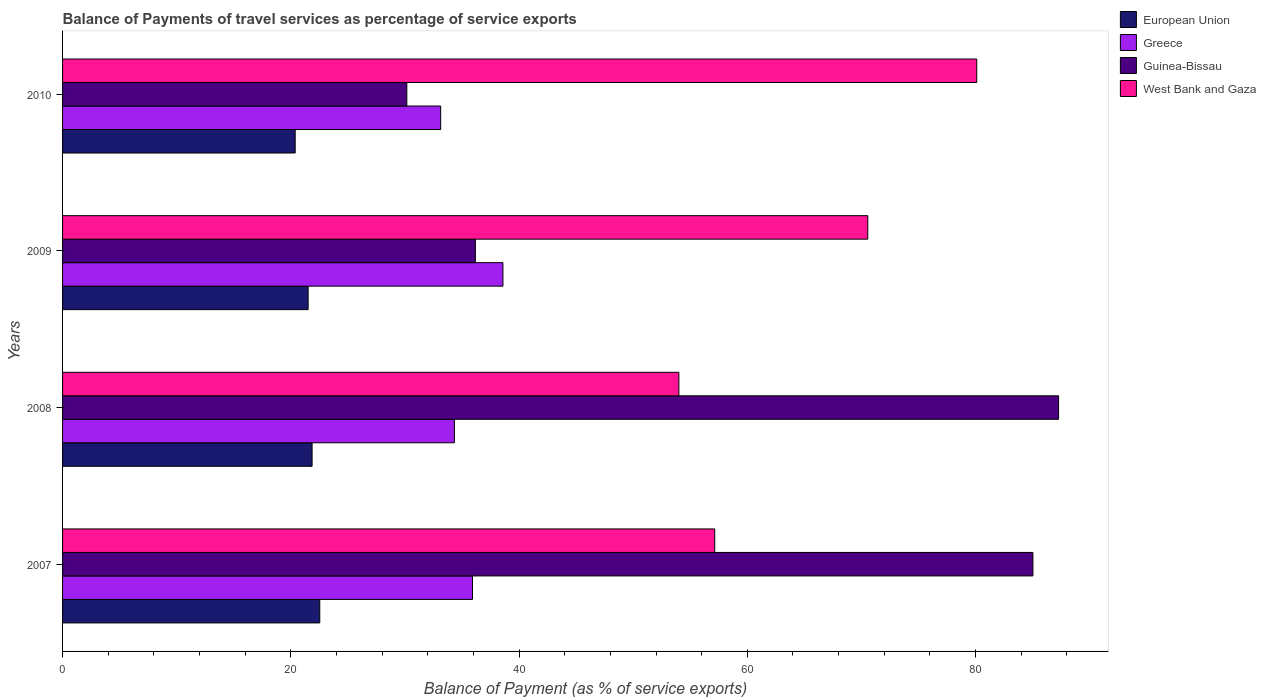How many different coloured bars are there?
Keep it short and to the point. 4. How many groups of bars are there?
Your response must be concise. 4. Are the number of bars on each tick of the Y-axis equal?
Make the answer very short. Yes. What is the balance of payments of travel services in West Bank and Gaza in 2007?
Ensure brevity in your answer.  57.14. Across all years, what is the maximum balance of payments of travel services in Greece?
Your answer should be very brief. 38.59. Across all years, what is the minimum balance of payments of travel services in West Bank and Gaza?
Provide a succinct answer. 54. In which year was the balance of payments of travel services in Guinea-Bissau maximum?
Your answer should be very brief. 2008. In which year was the balance of payments of travel services in European Union minimum?
Give a very brief answer. 2010. What is the total balance of payments of travel services in West Bank and Gaza in the graph?
Provide a short and direct response. 261.81. What is the difference between the balance of payments of travel services in Greece in 2007 and that in 2009?
Your answer should be very brief. -2.67. What is the difference between the balance of payments of travel services in West Bank and Gaza in 2009 and the balance of payments of travel services in European Union in 2008?
Keep it short and to the point. 48.69. What is the average balance of payments of travel services in Guinea-Bissau per year?
Make the answer very short. 59.66. In the year 2008, what is the difference between the balance of payments of travel services in West Bank and Gaza and balance of payments of travel services in Guinea-Bissau?
Provide a short and direct response. -33.27. What is the ratio of the balance of payments of travel services in Greece in 2008 to that in 2009?
Offer a very short reply. 0.89. What is the difference between the highest and the second highest balance of payments of travel services in West Bank and Gaza?
Your answer should be compact. 9.55. What is the difference between the highest and the lowest balance of payments of travel services in Greece?
Offer a very short reply. 5.46. Is the sum of the balance of payments of travel services in Greece in 2009 and 2010 greater than the maximum balance of payments of travel services in Guinea-Bissau across all years?
Make the answer very short. No. How many bars are there?
Make the answer very short. 16. What is the difference between two consecutive major ticks on the X-axis?
Give a very brief answer. 20. Are the values on the major ticks of X-axis written in scientific E-notation?
Offer a terse response. No. Does the graph contain any zero values?
Your response must be concise. No. Does the graph contain grids?
Ensure brevity in your answer.  No. How many legend labels are there?
Ensure brevity in your answer.  4. How are the legend labels stacked?
Your answer should be compact. Vertical. What is the title of the graph?
Give a very brief answer. Balance of Payments of travel services as percentage of service exports. What is the label or title of the X-axis?
Your response must be concise. Balance of Payment (as % of service exports). What is the Balance of Payment (as % of service exports) in European Union in 2007?
Offer a very short reply. 22.54. What is the Balance of Payment (as % of service exports) of Greece in 2007?
Your response must be concise. 35.92. What is the Balance of Payment (as % of service exports) of Guinea-Bissau in 2007?
Provide a succinct answer. 85.03. What is the Balance of Payment (as % of service exports) in West Bank and Gaza in 2007?
Keep it short and to the point. 57.14. What is the Balance of Payment (as % of service exports) in European Union in 2008?
Your answer should be very brief. 21.86. What is the Balance of Payment (as % of service exports) in Greece in 2008?
Offer a very short reply. 34.33. What is the Balance of Payment (as % of service exports) of Guinea-Bissau in 2008?
Your answer should be very brief. 87.27. What is the Balance of Payment (as % of service exports) of West Bank and Gaza in 2008?
Give a very brief answer. 54. What is the Balance of Payment (as % of service exports) in European Union in 2009?
Give a very brief answer. 21.52. What is the Balance of Payment (as % of service exports) in Greece in 2009?
Your answer should be very brief. 38.59. What is the Balance of Payment (as % of service exports) in Guinea-Bissau in 2009?
Provide a succinct answer. 36.17. What is the Balance of Payment (as % of service exports) in West Bank and Gaza in 2009?
Make the answer very short. 70.56. What is the Balance of Payment (as % of service exports) in European Union in 2010?
Offer a terse response. 20.38. What is the Balance of Payment (as % of service exports) of Greece in 2010?
Your response must be concise. 33.13. What is the Balance of Payment (as % of service exports) in Guinea-Bissau in 2010?
Provide a succinct answer. 30.17. What is the Balance of Payment (as % of service exports) of West Bank and Gaza in 2010?
Offer a very short reply. 80.1. Across all years, what is the maximum Balance of Payment (as % of service exports) in European Union?
Give a very brief answer. 22.54. Across all years, what is the maximum Balance of Payment (as % of service exports) in Greece?
Keep it short and to the point. 38.59. Across all years, what is the maximum Balance of Payment (as % of service exports) of Guinea-Bissau?
Offer a terse response. 87.27. Across all years, what is the maximum Balance of Payment (as % of service exports) of West Bank and Gaza?
Provide a succinct answer. 80.1. Across all years, what is the minimum Balance of Payment (as % of service exports) in European Union?
Give a very brief answer. 20.38. Across all years, what is the minimum Balance of Payment (as % of service exports) in Greece?
Make the answer very short. 33.13. Across all years, what is the minimum Balance of Payment (as % of service exports) of Guinea-Bissau?
Give a very brief answer. 30.17. Across all years, what is the minimum Balance of Payment (as % of service exports) of West Bank and Gaza?
Make the answer very short. 54. What is the total Balance of Payment (as % of service exports) of European Union in the graph?
Your answer should be very brief. 86.3. What is the total Balance of Payment (as % of service exports) of Greece in the graph?
Provide a short and direct response. 141.97. What is the total Balance of Payment (as % of service exports) in Guinea-Bissau in the graph?
Provide a short and direct response. 238.64. What is the total Balance of Payment (as % of service exports) in West Bank and Gaza in the graph?
Offer a very short reply. 261.81. What is the difference between the Balance of Payment (as % of service exports) of European Union in 2007 and that in 2008?
Your answer should be compact. 0.67. What is the difference between the Balance of Payment (as % of service exports) in Greece in 2007 and that in 2008?
Your response must be concise. 1.59. What is the difference between the Balance of Payment (as % of service exports) of Guinea-Bissau in 2007 and that in 2008?
Provide a short and direct response. -2.25. What is the difference between the Balance of Payment (as % of service exports) of West Bank and Gaza in 2007 and that in 2008?
Make the answer very short. 3.14. What is the difference between the Balance of Payment (as % of service exports) in European Union in 2007 and that in 2009?
Offer a very short reply. 1.02. What is the difference between the Balance of Payment (as % of service exports) of Greece in 2007 and that in 2009?
Your answer should be very brief. -2.67. What is the difference between the Balance of Payment (as % of service exports) in Guinea-Bissau in 2007 and that in 2009?
Your response must be concise. 48.85. What is the difference between the Balance of Payment (as % of service exports) of West Bank and Gaza in 2007 and that in 2009?
Your answer should be very brief. -13.41. What is the difference between the Balance of Payment (as % of service exports) in European Union in 2007 and that in 2010?
Offer a terse response. 2.15. What is the difference between the Balance of Payment (as % of service exports) in Greece in 2007 and that in 2010?
Offer a very short reply. 2.79. What is the difference between the Balance of Payment (as % of service exports) in Guinea-Bissau in 2007 and that in 2010?
Offer a terse response. 54.86. What is the difference between the Balance of Payment (as % of service exports) of West Bank and Gaza in 2007 and that in 2010?
Give a very brief answer. -22.96. What is the difference between the Balance of Payment (as % of service exports) in European Union in 2008 and that in 2009?
Your answer should be very brief. 0.35. What is the difference between the Balance of Payment (as % of service exports) in Greece in 2008 and that in 2009?
Provide a short and direct response. -4.25. What is the difference between the Balance of Payment (as % of service exports) of Guinea-Bissau in 2008 and that in 2009?
Make the answer very short. 51.1. What is the difference between the Balance of Payment (as % of service exports) of West Bank and Gaza in 2008 and that in 2009?
Give a very brief answer. -16.55. What is the difference between the Balance of Payment (as % of service exports) of European Union in 2008 and that in 2010?
Give a very brief answer. 1.48. What is the difference between the Balance of Payment (as % of service exports) of Greece in 2008 and that in 2010?
Ensure brevity in your answer.  1.2. What is the difference between the Balance of Payment (as % of service exports) of Guinea-Bissau in 2008 and that in 2010?
Your answer should be very brief. 57.11. What is the difference between the Balance of Payment (as % of service exports) of West Bank and Gaza in 2008 and that in 2010?
Offer a very short reply. -26.1. What is the difference between the Balance of Payment (as % of service exports) in European Union in 2009 and that in 2010?
Provide a short and direct response. 1.13. What is the difference between the Balance of Payment (as % of service exports) in Greece in 2009 and that in 2010?
Your answer should be very brief. 5.46. What is the difference between the Balance of Payment (as % of service exports) in Guinea-Bissau in 2009 and that in 2010?
Give a very brief answer. 6.01. What is the difference between the Balance of Payment (as % of service exports) of West Bank and Gaza in 2009 and that in 2010?
Offer a very short reply. -9.55. What is the difference between the Balance of Payment (as % of service exports) in European Union in 2007 and the Balance of Payment (as % of service exports) in Greece in 2008?
Provide a short and direct response. -11.8. What is the difference between the Balance of Payment (as % of service exports) of European Union in 2007 and the Balance of Payment (as % of service exports) of Guinea-Bissau in 2008?
Your response must be concise. -64.74. What is the difference between the Balance of Payment (as % of service exports) of European Union in 2007 and the Balance of Payment (as % of service exports) of West Bank and Gaza in 2008?
Keep it short and to the point. -31.47. What is the difference between the Balance of Payment (as % of service exports) in Greece in 2007 and the Balance of Payment (as % of service exports) in Guinea-Bissau in 2008?
Offer a very short reply. -51.35. What is the difference between the Balance of Payment (as % of service exports) in Greece in 2007 and the Balance of Payment (as % of service exports) in West Bank and Gaza in 2008?
Make the answer very short. -18.08. What is the difference between the Balance of Payment (as % of service exports) of Guinea-Bissau in 2007 and the Balance of Payment (as % of service exports) of West Bank and Gaza in 2008?
Provide a short and direct response. 31.02. What is the difference between the Balance of Payment (as % of service exports) of European Union in 2007 and the Balance of Payment (as % of service exports) of Greece in 2009?
Your answer should be very brief. -16.05. What is the difference between the Balance of Payment (as % of service exports) of European Union in 2007 and the Balance of Payment (as % of service exports) of Guinea-Bissau in 2009?
Your answer should be very brief. -13.63. What is the difference between the Balance of Payment (as % of service exports) of European Union in 2007 and the Balance of Payment (as % of service exports) of West Bank and Gaza in 2009?
Your response must be concise. -48.02. What is the difference between the Balance of Payment (as % of service exports) of Greece in 2007 and the Balance of Payment (as % of service exports) of Guinea-Bissau in 2009?
Offer a terse response. -0.25. What is the difference between the Balance of Payment (as % of service exports) of Greece in 2007 and the Balance of Payment (as % of service exports) of West Bank and Gaza in 2009?
Offer a very short reply. -34.64. What is the difference between the Balance of Payment (as % of service exports) in Guinea-Bissau in 2007 and the Balance of Payment (as % of service exports) in West Bank and Gaza in 2009?
Offer a terse response. 14.47. What is the difference between the Balance of Payment (as % of service exports) of European Union in 2007 and the Balance of Payment (as % of service exports) of Greece in 2010?
Keep it short and to the point. -10.59. What is the difference between the Balance of Payment (as % of service exports) in European Union in 2007 and the Balance of Payment (as % of service exports) in Guinea-Bissau in 2010?
Provide a succinct answer. -7.63. What is the difference between the Balance of Payment (as % of service exports) in European Union in 2007 and the Balance of Payment (as % of service exports) in West Bank and Gaza in 2010?
Make the answer very short. -57.57. What is the difference between the Balance of Payment (as % of service exports) in Greece in 2007 and the Balance of Payment (as % of service exports) in Guinea-Bissau in 2010?
Provide a short and direct response. 5.75. What is the difference between the Balance of Payment (as % of service exports) of Greece in 2007 and the Balance of Payment (as % of service exports) of West Bank and Gaza in 2010?
Give a very brief answer. -44.18. What is the difference between the Balance of Payment (as % of service exports) in Guinea-Bissau in 2007 and the Balance of Payment (as % of service exports) in West Bank and Gaza in 2010?
Offer a terse response. 4.92. What is the difference between the Balance of Payment (as % of service exports) in European Union in 2008 and the Balance of Payment (as % of service exports) in Greece in 2009?
Offer a terse response. -16.72. What is the difference between the Balance of Payment (as % of service exports) of European Union in 2008 and the Balance of Payment (as % of service exports) of Guinea-Bissau in 2009?
Offer a terse response. -14.31. What is the difference between the Balance of Payment (as % of service exports) of European Union in 2008 and the Balance of Payment (as % of service exports) of West Bank and Gaza in 2009?
Offer a very short reply. -48.69. What is the difference between the Balance of Payment (as % of service exports) in Greece in 2008 and the Balance of Payment (as % of service exports) in Guinea-Bissau in 2009?
Make the answer very short. -1.84. What is the difference between the Balance of Payment (as % of service exports) of Greece in 2008 and the Balance of Payment (as % of service exports) of West Bank and Gaza in 2009?
Provide a short and direct response. -36.22. What is the difference between the Balance of Payment (as % of service exports) of Guinea-Bissau in 2008 and the Balance of Payment (as % of service exports) of West Bank and Gaza in 2009?
Provide a short and direct response. 16.72. What is the difference between the Balance of Payment (as % of service exports) of European Union in 2008 and the Balance of Payment (as % of service exports) of Greece in 2010?
Keep it short and to the point. -11.27. What is the difference between the Balance of Payment (as % of service exports) in European Union in 2008 and the Balance of Payment (as % of service exports) in Guinea-Bissau in 2010?
Offer a terse response. -8.3. What is the difference between the Balance of Payment (as % of service exports) in European Union in 2008 and the Balance of Payment (as % of service exports) in West Bank and Gaza in 2010?
Offer a terse response. -58.24. What is the difference between the Balance of Payment (as % of service exports) in Greece in 2008 and the Balance of Payment (as % of service exports) in Guinea-Bissau in 2010?
Ensure brevity in your answer.  4.17. What is the difference between the Balance of Payment (as % of service exports) of Greece in 2008 and the Balance of Payment (as % of service exports) of West Bank and Gaza in 2010?
Make the answer very short. -45.77. What is the difference between the Balance of Payment (as % of service exports) of Guinea-Bissau in 2008 and the Balance of Payment (as % of service exports) of West Bank and Gaza in 2010?
Give a very brief answer. 7.17. What is the difference between the Balance of Payment (as % of service exports) in European Union in 2009 and the Balance of Payment (as % of service exports) in Greece in 2010?
Your answer should be compact. -11.61. What is the difference between the Balance of Payment (as % of service exports) of European Union in 2009 and the Balance of Payment (as % of service exports) of Guinea-Bissau in 2010?
Ensure brevity in your answer.  -8.65. What is the difference between the Balance of Payment (as % of service exports) of European Union in 2009 and the Balance of Payment (as % of service exports) of West Bank and Gaza in 2010?
Make the answer very short. -58.59. What is the difference between the Balance of Payment (as % of service exports) in Greece in 2009 and the Balance of Payment (as % of service exports) in Guinea-Bissau in 2010?
Provide a short and direct response. 8.42. What is the difference between the Balance of Payment (as % of service exports) of Greece in 2009 and the Balance of Payment (as % of service exports) of West Bank and Gaza in 2010?
Provide a succinct answer. -41.52. What is the difference between the Balance of Payment (as % of service exports) in Guinea-Bissau in 2009 and the Balance of Payment (as % of service exports) in West Bank and Gaza in 2010?
Offer a very short reply. -43.93. What is the average Balance of Payment (as % of service exports) in European Union per year?
Ensure brevity in your answer.  21.58. What is the average Balance of Payment (as % of service exports) of Greece per year?
Your answer should be compact. 35.49. What is the average Balance of Payment (as % of service exports) of Guinea-Bissau per year?
Provide a short and direct response. 59.66. What is the average Balance of Payment (as % of service exports) in West Bank and Gaza per year?
Ensure brevity in your answer.  65.45. In the year 2007, what is the difference between the Balance of Payment (as % of service exports) in European Union and Balance of Payment (as % of service exports) in Greece?
Give a very brief answer. -13.38. In the year 2007, what is the difference between the Balance of Payment (as % of service exports) in European Union and Balance of Payment (as % of service exports) in Guinea-Bissau?
Offer a terse response. -62.49. In the year 2007, what is the difference between the Balance of Payment (as % of service exports) in European Union and Balance of Payment (as % of service exports) in West Bank and Gaza?
Provide a succinct answer. -34.61. In the year 2007, what is the difference between the Balance of Payment (as % of service exports) of Greece and Balance of Payment (as % of service exports) of Guinea-Bissau?
Give a very brief answer. -49.1. In the year 2007, what is the difference between the Balance of Payment (as % of service exports) of Greece and Balance of Payment (as % of service exports) of West Bank and Gaza?
Offer a terse response. -21.22. In the year 2007, what is the difference between the Balance of Payment (as % of service exports) in Guinea-Bissau and Balance of Payment (as % of service exports) in West Bank and Gaza?
Ensure brevity in your answer.  27.88. In the year 2008, what is the difference between the Balance of Payment (as % of service exports) in European Union and Balance of Payment (as % of service exports) in Greece?
Offer a terse response. -12.47. In the year 2008, what is the difference between the Balance of Payment (as % of service exports) of European Union and Balance of Payment (as % of service exports) of Guinea-Bissau?
Make the answer very short. -65.41. In the year 2008, what is the difference between the Balance of Payment (as % of service exports) in European Union and Balance of Payment (as % of service exports) in West Bank and Gaza?
Give a very brief answer. -32.14. In the year 2008, what is the difference between the Balance of Payment (as % of service exports) in Greece and Balance of Payment (as % of service exports) in Guinea-Bissau?
Give a very brief answer. -52.94. In the year 2008, what is the difference between the Balance of Payment (as % of service exports) of Greece and Balance of Payment (as % of service exports) of West Bank and Gaza?
Your answer should be very brief. -19.67. In the year 2008, what is the difference between the Balance of Payment (as % of service exports) of Guinea-Bissau and Balance of Payment (as % of service exports) of West Bank and Gaza?
Provide a succinct answer. 33.27. In the year 2009, what is the difference between the Balance of Payment (as % of service exports) of European Union and Balance of Payment (as % of service exports) of Greece?
Offer a very short reply. -17.07. In the year 2009, what is the difference between the Balance of Payment (as % of service exports) in European Union and Balance of Payment (as % of service exports) in Guinea-Bissau?
Your answer should be very brief. -14.66. In the year 2009, what is the difference between the Balance of Payment (as % of service exports) in European Union and Balance of Payment (as % of service exports) in West Bank and Gaza?
Your answer should be compact. -49.04. In the year 2009, what is the difference between the Balance of Payment (as % of service exports) of Greece and Balance of Payment (as % of service exports) of Guinea-Bissau?
Give a very brief answer. 2.42. In the year 2009, what is the difference between the Balance of Payment (as % of service exports) in Greece and Balance of Payment (as % of service exports) in West Bank and Gaza?
Offer a very short reply. -31.97. In the year 2009, what is the difference between the Balance of Payment (as % of service exports) of Guinea-Bissau and Balance of Payment (as % of service exports) of West Bank and Gaza?
Make the answer very short. -34.38. In the year 2010, what is the difference between the Balance of Payment (as % of service exports) in European Union and Balance of Payment (as % of service exports) in Greece?
Give a very brief answer. -12.75. In the year 2010, what is the difference between the Balance of Payment (as % of service exports) in European Union and Balance of Payment (as % of service exports) in Guinea-Bissau?
Your answer should be compact. -9.78. In the year 2010, what is the difference between the Balance of Payment (as % of service exports) in European Union and Balance of Payment (as % of service exports) in West Bank and Gaza?
Keep it short and to the point. -59.72. In the year 2010, what is the difference between the Balance of Payment (as % of service exports) in Greece and Balance of Payment (as % of service exports) in Guinea-Bissau?
Your answer should be compact. 2.96. In the year 2010, what is the difference between the Balance of Payment (as % of service exports) of Greece and Balance of Payment (as % of service exports) of West Bank and Gaza?
Ensure brevity in your answer.  -46.97. In the year 2010, what is the difference between the Balance of Payment (as % of service exports) in Guinea-Bissau and Balance of Payment (as % of service exports) in West Bank and Gaza?
Give a very brief answer. -49.94. What is the ratio of the Balance of Payment (as % of service exports) in European Union in 2007 to that in 2008?
Ensure brevity in your answer.  1.03. What is the ratio of the Balance of Payment (as % of service exports) in Greece in 2007 to that in 2008?
Your response must be concise. 1.05. What is the ratio of the Balance of Payment (as % of service exports) in Guinea-Bissau in 2007 to that in 2008?
Provide a short and direct response. 0.97. What is the ratio of the Balance of Payment (as % of service exports) of West Bank and Gaza in 2007 to that in 2008?
Your answer should be very brief. 1.06. What is the ratio of the Balance of Payment (as % of service exports) of European Union in 2007 to that in 2009?
Your response must be concise. 1.05. What is the ratio of the Balance of Payment (as % of service exports) of Greece in 2007 to that in 2009?
Make the answer very short. 0.93. What is the ratio of the Balance of Payment (as % of service exports) of Guinea-Bissau in 2007 to that in 2009?
Give a very brief answer. 2.35. What is the ratio of the Balance of Payment (as % of service exports) in West Bank and Gaza in 2007 to that in 2009?
Provide a short and direct response. 0.81. What is the ratio of the Balance of Payment (as % of service exports) in European Union in 2007 to that in 2010?
Offer a very short reply. 1.11. What is the ratio of the Balance of Payment (as % of service exports) in Greece in 2007 to that in 2010?
Make the answer very short. 1.08. What is the ratio of the Balance of Payment (as % of service exports) of Guinea-Bissau in 2007 to that in 2010?
Provide a short and direct response. 2.82. What is the ratio of the Balance of Payment (as % of service exports) of West Bank and Gaza in 2007 to that in 2010?
Your answer should be compact. 0.71. What is the ratio of the Balance of Payment (as % of service exports) of European Union in 2008 to that in 2009?
Your response must be concise. 1.02. What is the ratio of the Balance of Payment (as % of service exports) of Greece in 2008 to that in 2009?
Offer a very short reply. 0.89. What is the ratio of the Balance of Payment (as % of service exports) in Guinea-Bissau in 2008 to that in 2009?
Provide a short and direct response. 2.41. What is the ratio of the Balance of Payment (as % of service exports) of West Bank and Gaza in 2008 to that in 2009?
Your response must be concise. 0.77. What is the ratio of the Balance of Payment (as % of service exports) in European Union in 2008 to that in 2010?
Make the answer very short. 1.07. What is the ratio of the Balance of Payment (as % of service exports) of Greece in 2008 to that in 2010?
Give a very brief answer. 1.04. What is the ratio of the Balance of Payment (as % of service exports) of Guinea-Bissau in 2008 to that in 2010?
Your response must be concise. 2.89. What is the ratio of the Balance of Payment (as % of service exports) in West Bank and Gaza in 2008 to that in 2010?
Your response must be concise. 0.67. What is the ratio of the Balance of Payment (as % of service exports) in European Union in 2009 to that in 2010?
Your answer should be compact. 1.06. What is the ratio of the Balance of Payment (as % of service exports) in Greece in 2009 to that in 2010?
Give a very brief answer. 1.16. What is the ratio of the Balance of Payment (as % of service exports) in Guinea-Bissau in 2009 to that in 2010?
Provide a succinct answer. 1.2. What is the ratio of the Balance of Payment (as % of service exports) of West Bank and Gaza in 2009 to that in 2010?
Make the answer very short. 0.88. What is the difference between the highest and the second highest Balance of Payment (as % of service exports) in European Union?
Your response must be concise. 0.67. What is the difference between the highest and the second highest Balance of Payment (as % of service exports) in Greece?
Your answer should be compact. 2.67. What is the difference between the highest and the second highest Balance of Payment (as % of service exports) of Guinea-Bissau?
Provide a succinct answer. 2.25. What is the difference between the highest and the second highest Balance of Payment (as % of service exports) in West Bank and Gaza?
Make the answer very short. 9.55. What is the difference between the highest and the lowest Balance of Payment (as % of service exports) of European Union?
Ensure brevity in your answer.  2.15. What is the difference between the highest and the lowest Balance of Payment (as % of service exports) of Greece?
Provide a short and direct response. 5.46. What is the difference between the highest and the lowest Balance of Payment (as % of service exports) in Guinea-Bissau?
Give a very brief answer. 57.11. What is the difference between the highest and the lowest Balance of Payment (as % of service exports) in West Bank and Gaza?
Your response must be concise. 26.1. 